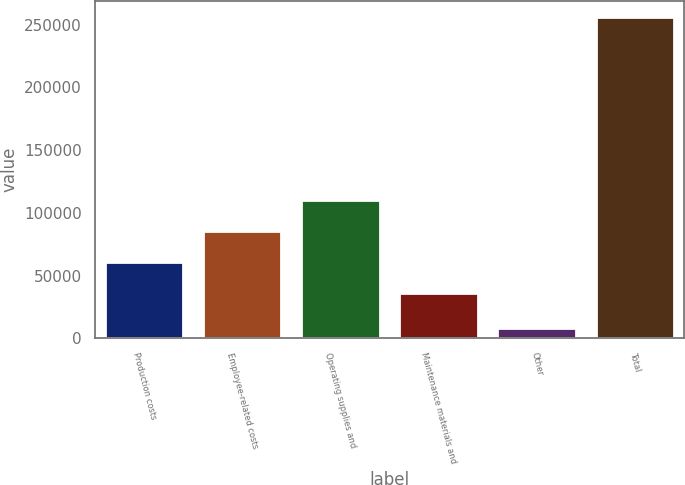Convert chart to OTSL. <chart><loc_0><loc_0><loc_500><loc_500><bar_chart><fcel>Production costs<fcel>Employee-related costs<fcel>Operating supplies and<fcel>Maintenance materials and<fcel>Other<fcel>Total<nl><fcel>60943.1<fcel>85751.2<fcel>110559<fcel>36135<fcel>8188<fcel>256269<nl></chart> 